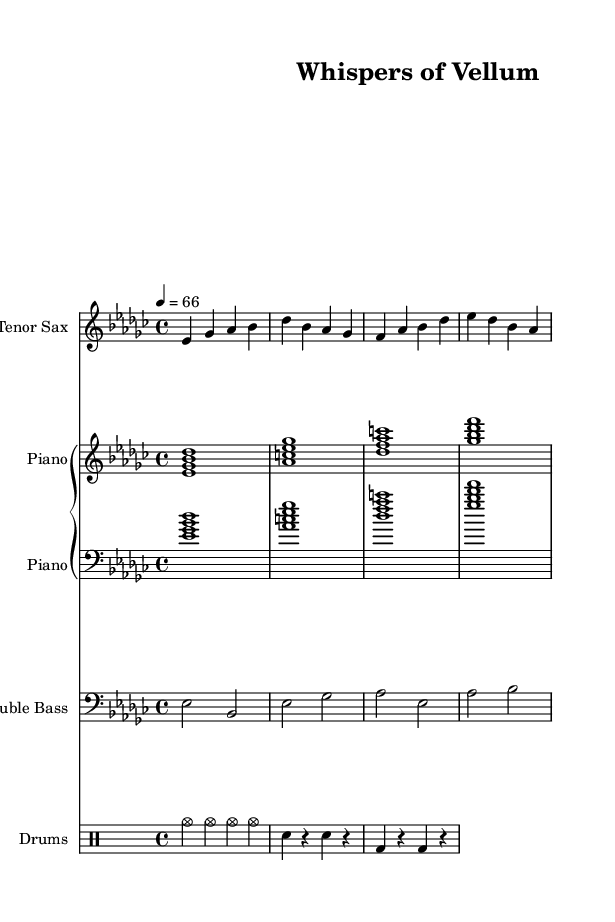What is the key signature of this music? The key signature contains three flats: B flat, E flat, and A flat, which indicates that the music is in E flat minor.
Answer: E flat minor What is the time signature of this music? The time signature is indicated at the beginning of the sheet music, showing a 4/4 time, meaning there are four beats in each measure.
Answer: 4/4 What is the tempo marking given for this piece? The tempo marking is shown as a metronome mark of 66 beats per minute, indicating a slow to moderate speed.
Answer: 66 How many measures are there in the saxophone part? Counting the measures in the saxophone part yields a total of four measures as separated by vertical lines on the staff.
Answer: 4 Which instrument plays the longest note value in this score? Analyzing the note values reveals that the piano part has whole notes, particularly indicated by sustained chords, while the drums play shorter notes. Therefore, the piano has the longest overall note values.
Answer: Piano What type of jazz is this piece an example of? This piece, characterized by its cool harmonies and moderate tempo, reflects characteristics typical of cool jazz, focusing more on arrangement and subtler emotions.
Answer: Cool jazz What does the drum pattern primarily use? The drum pattern prominently features cymbals throughout the piece with a steady rhythm, especially indicated with repeated measures emphasizing the ride cymbal.
Answer: Cymbals 